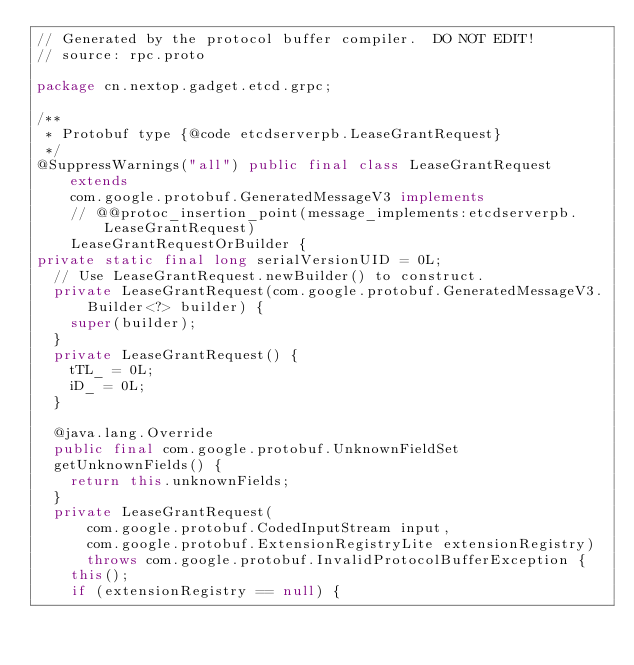<code> <loc_0><loc_0><loc_500><loc_500><_Java_>// Generated by the protocol buffer compiler.  DO NOT EDIT!
// source: rpc.proto

package cn.nextop.gadget.etcd.grpc;

/**
 * Protobuf type {@code etcdserverpb.LeaseGrantRequest}
 */
@SuppressWarnings("all") public final class LeaseGrantRequest extends
    com.google.protobuf.GeneratedMessageV3 implements
    // @@protoc_insertion_point(message_implements:etcdserverpb.LeaseGrantRequest)
    LeaseGrantRequestOrBuilder {
private static final long serialVersionUID = 0L;
  // Use LeaseGrantRequest.newBuilder() to construct.
  private LeaseGrantRequest(com.google.protobuf.GeneratedMessageV3.Builder<?> builder) {
    super(builder);
  }
  private LeaseGrantRequest() {
    tTL_ = 0L;
    iD_ = 0L;
  }

  @java.lang.Override
  public final com.google.protobuf.UnknownFieldSet
  getUnknownFields() {
    return this.unknownFields;
  }
  private LeaseGrantRequest(
      com.google.protobuf.CodedInputStream input,
      com.google.protobuf.ExtensionRegistryLite extensionRegistry)
      throws com.google.protobuf.InvalidProtocolBufferException {
    this();
    if (extensionRegistry == null) {</code> 